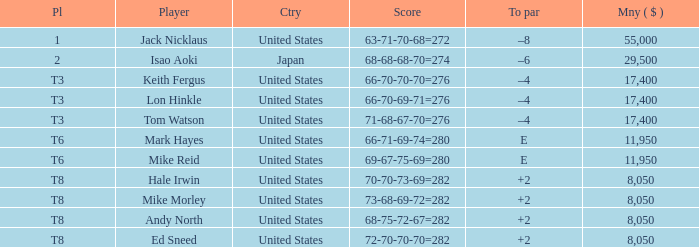In which american golf facility can you find a player called hale irwin? 2.0. 